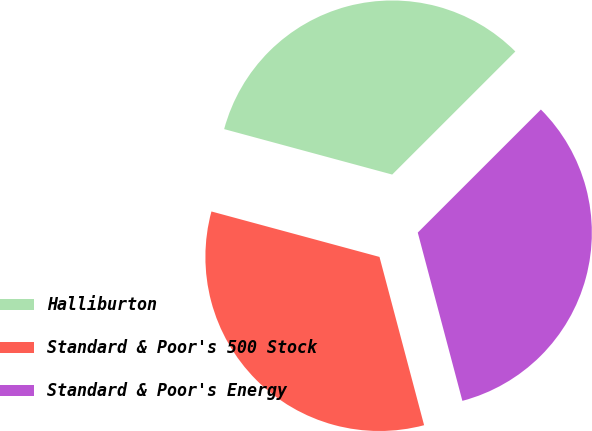Convert chart. <chart><loc_0><loc_0><loc_500><loc_500><pie_chart><fcel>Halliburton<fcel>Standard & Poor's 500 Stock<fcel>Standard & Poor's Energy<nl><fcel>33.3%<fcel>33.33%<fcel>33.37%<nl></chart> 